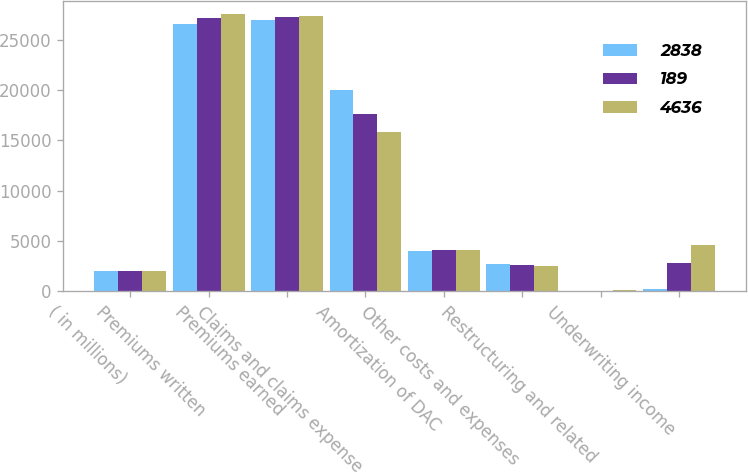Convert chart to OTSL. <chart><loc_0><loc_0><loc_500><loc_500><stacked_bar_chart><ecel><fcel>( in millions)<fcel>Premiums written<fcel>Premiums earned<fcel>Claims and claims expense<fcel>Amortization of DAC<fcel>Other costs and expenses<fcel>Restructuring and related<fcel>Underwriting income<nl><fcel>2838<fcel>2008<fcel>26584<fcel>26967<fcel>20046<fcel>3975<fcel>2735<fcel>22<fcel>189<nl><fcel>189<fcel>2007<fcel>27183<fcel>27232<fcel>17620<fcel>4121<fcel>2626<fcel>27<fcel>2838<nl><fcel>4636<fcel>2006<fcel>27525<fcel>27366<fcel>15885<fcel>4131<fcel>2557<fcel>157<fcel>4636<nl></chart> 